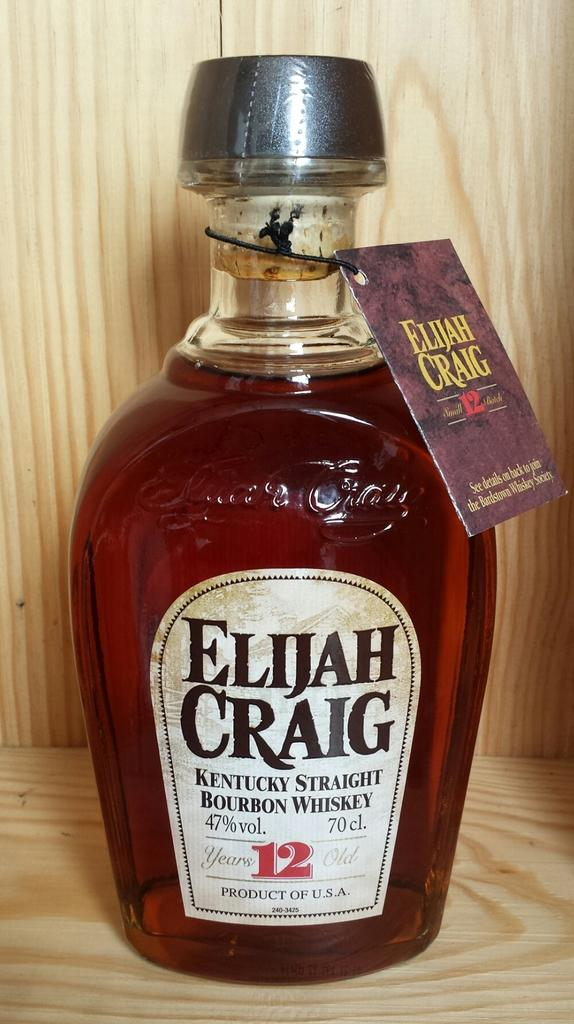<image>
Present a compact description of the photo's key features. A full bottle of bourbon whiskey is still sealed with a hang tag. 